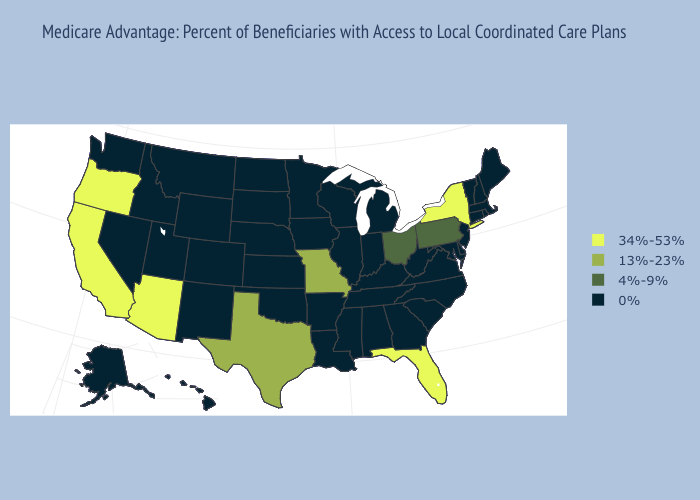Name the states that have a value in the range 4%-9%?
Give a very brief answer. Ohio, Pennsylvania. Does Louisiana have a higher value than New Mexico?
Be succinct. No. Name the states that have a value in the range 34%-53%?
Keep it brief. Arizona, California, Florida, New York, Oregon. What is the value of Texas?
Answer briefly. 13%-23%. Name the states that have a value in the range 13%-23%?
Concise answer only. Missouri, Texas. Name the states that have a value in the range 4%-9%?
Keep it brief. Ohio, Pennsylvania. Does the first symbol in the legend represent the smallest category?
Quick response, please. No. Name the states that have a value in the range 0%?
Keep it brief. Alaska, Alabama, Arkansas, Colorado, Connecticut, Delaware, Georgia, Hawaii, Iowa, Idaho, Illinois, Indiana, Kansas, Kentucky, Louisiana, Massachusetts, Maryland, Maine, Michigan, Minnesota, Mississippi, Montana, North Carolina, North Dakota, Nebraska, New Hampshire, New Jersey, New Mexico, Nevada, Oklahoma, Rhode Island, South Carolina, South Dakota, Tennessee, Utah, Virginia, Vermont, Washington, Wisconsin, West Virginia, Wyoming. What is the lowest value in the MidWest?
Concise answer only. 0%. Does Virginia have a lower value than New York?
Give a very brief answer. Yes. What is the value of Iowa?
Be succinct. 0%. Does Pennsylvania have the lowest value in the Northeast?
Short answer required. No. Does Massachusetts have a higher value than Delaware?
Write a very short answer. No. What is the value of Indiana?
Keep it brief. 0%. Which states have the lowest value in the USA?
Concise answer only. Alaska, Alabama, Arkansas, Colorado, Connecticut, Delaware, Georgia, Hawaii, Iowa, Idaho, Illinois, Indiana, Kansas, Kentucky, Louisiana, Massachusetts, Maryland, Maine, Michigan, Minnesota, Mississippi, Montana, North Carolina, North Dakota, Nebraska, New Hampshire, New Jersey, New Mexico, Nevada, Oklahoma, Rhode Island, South Carolina, South Dakota, Tennessee, Utah, Virginia, Vermont, Washington, Wisconsin, West Virginia, Wyoming. 